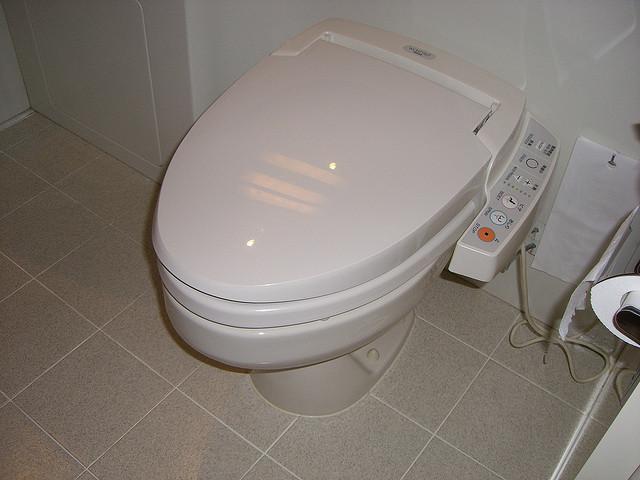Is there a black dot on the orange button?
Give a very brief answer. Yes. What color is the floor?
Write a very short answer. White. Is this floor messy?
Write a very short answer. No. Is this a toilet for disabled people?
Answer briefly. Yes. Is the toilet cover up or down?
Concise answer only. Down. 